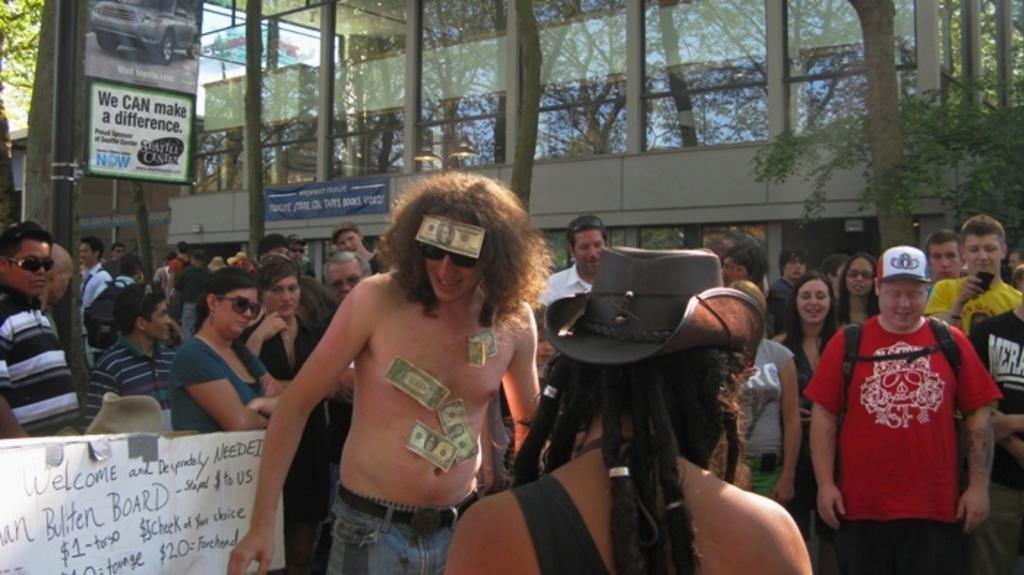How would you summarize this image in a sentence or two? There are people standing in the foreground area of the image, some are holding a poster and there are currency notes on the body of a person. There are trees, posters and a building in the background. 